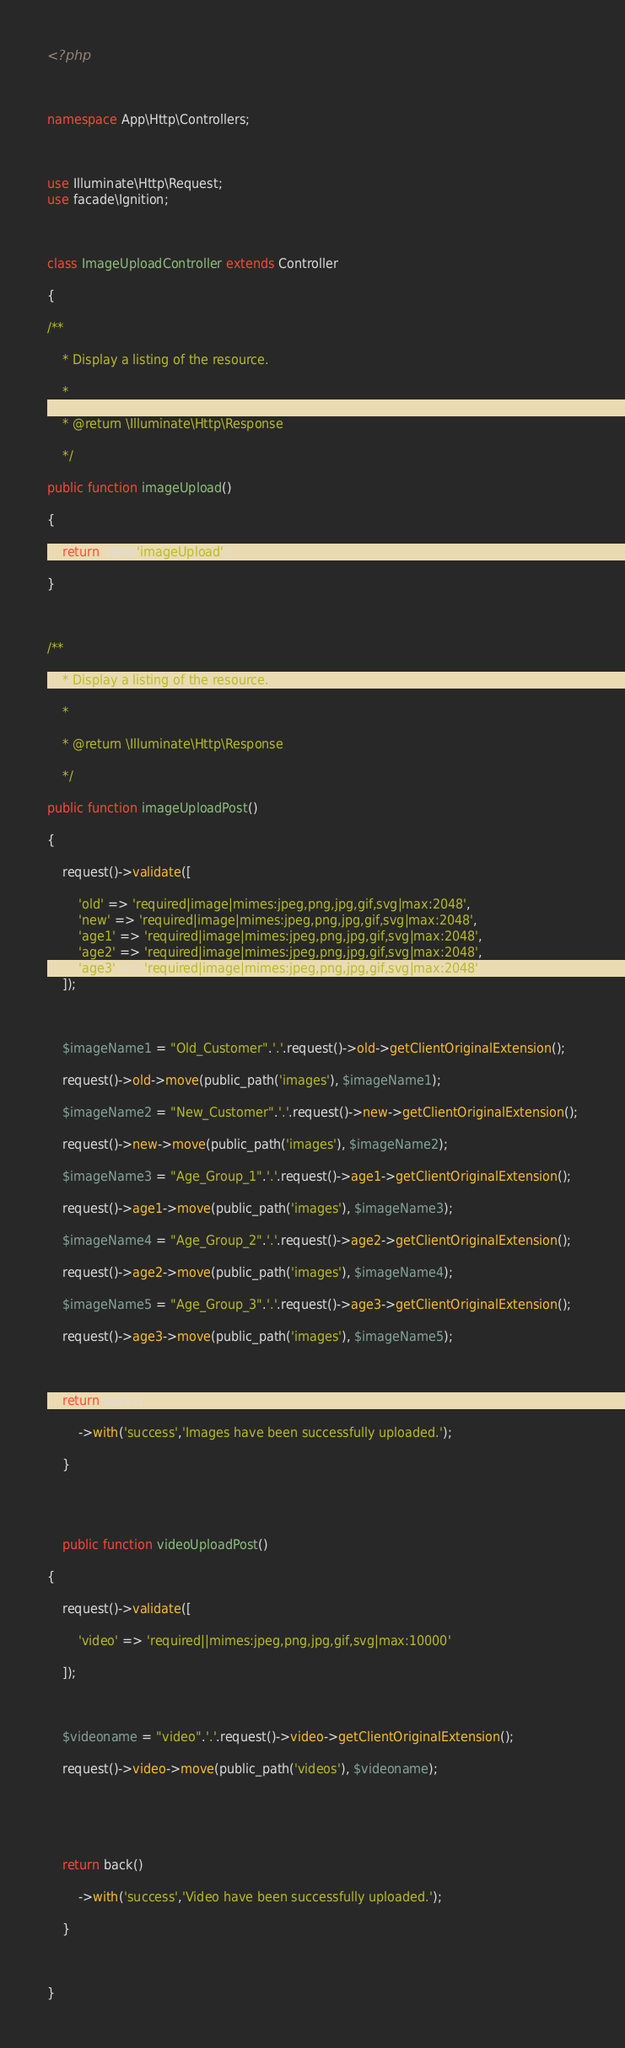Convert code to text. <code><loc_0><loc_0><loc_500><loc_500><_PHP_><?php



namespace App\Http\Controllers;



use Illuminate\Http\Request;
use facade\Ignition;



class ImageUploadController extends Controller

{

/**

    * Display a listing of the resource.

    *

    * @return \Illuminate\Http\Response

    */

public function imageUpload()

{

    return view('imageUpload');

}



/**

    * Display a listing of the resource.

    *

    * @return \Illuminate\Http\Response

    */

public function imageUploadPost()

{

    request()->validate([

        'old' => 'required|image|mimes:jpeg,png,jpg,gif,svg|max:2048',
        'new' => 'required|image|mimes:jpeg,png,jpg,gif,svg|max:2048',
        'age1' => 'required|image|mimes:jpeg,png,jpg,gif,svg|max:2048',
        'age2' => 'required|image|mimes:jpeg,png,jpg,gif,svg|max:2048',
        'age3' => 'required|image|mimes:jpeg,png,jpg,gif,svg|max:2048',
    ]);



    $imageName1 = "Old_Customer".'.'.request()->old->getClientOriginalExtension();

    request()->old->move(public_path('images'), $imageName1);

    $imageName2 = "New_Customer".'.'.request()->new->getClientOriginalExtension();

    request()->new->move(public_path('images'), $imageName2);

    $imageName3 = "Age_Group_1".'.'.request()->age1->getClientOriginalExtension();

    request()->age1->move(public_path('images'), $imageName3);

    $imageName4 = "Age_Group_2".'.'.request()->age2->getClientOriginalExtension();

    request()->age2->move(public_path('images'), $imageName4);

    $imageName5 = "Age_Group_3".'.'.request()->age3->getClientOriginalExtension();

    request()->age3->move(public_path('images'), $imageName5);

    

    return back()

        ->with('success','Images have been successfully uploaded.');

    }




    public function videoUploadPost()

{

    request()->validate([

        'video' => 'required||mimes:jpeg,png,jpg,gif,svg|max:10000'
    
    ]);



    $videoname = "video".'.'.request()->video->getClientOriginalExtension();

    request()->video->move(public_path('videos'), $videoname);



    

    return back()

        ->with('success','Video have been successfully uploaded.');

    }



}</code> 